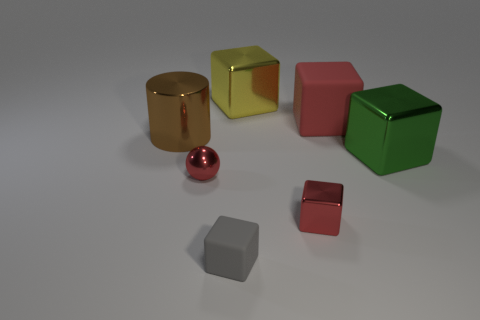Can you guess the material of the objects? Based on their appearance, it seems that the objects are made of different materials. The cubes and the small sphere likely have a polished, reflective surface, which might indicate a metallic or plastic material. The larger cylinder has a more muted reflection, possibly suggesting a matte metal or painted wood. 